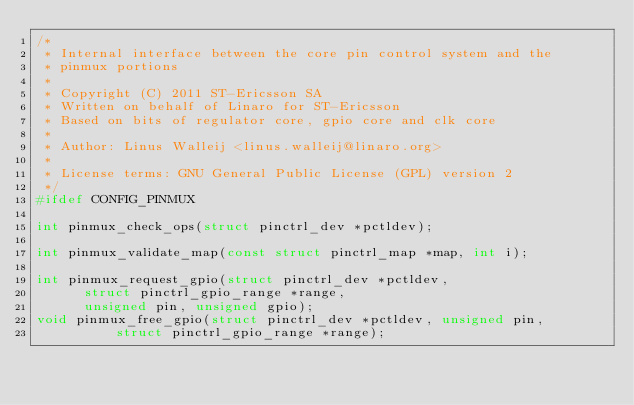Convert code to text. <code><loc_0><loc_0><loc_500><loc_500><_C_>/*
 * Internal interface between the core pin control system and the
 * pinmux portions
 *
 * Copyright (C) 2011 ST-Ericsson SA
 * Written on behalf of Linaro for ST-Ericsson
 * Based on bits of regulator core, gpio core and clk core
 *
 * Author: Linus Walleij <linus.walleij@linaro.org>
 *
 * License terms: GNU General Public License (GPL) version 2
 */
#ifdef CONFIG_PINMUX

int pinmux_check_ops(struct pinctrl_dev *pctldev);

int pinmux_validate_map(const struct pinctrl_map *map, int i);

int pinmux_request_gpio(struct pinctrl_dev *pctldev,
			struct pinctrl_gpio_range *range,
			unsigned pin, unsigned gpio);
void pinmux_free_gpio(struct pinctrl_dev *pctldev, unsigned pin,
		      struct pinctrl_gpio_range *range);</code> 